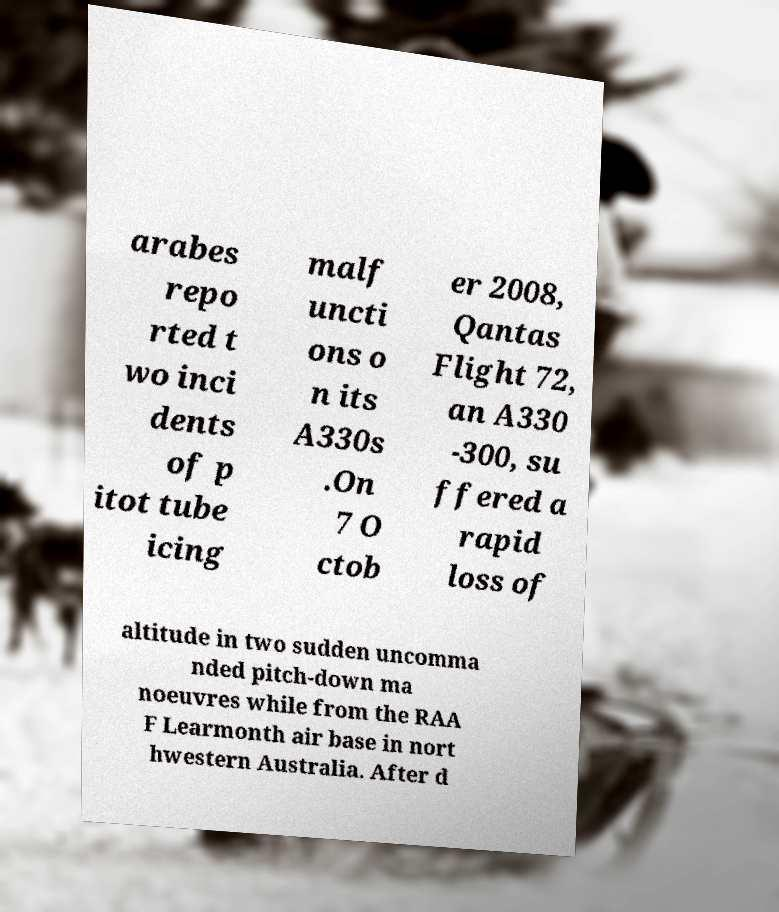Please read and relay the text visible in this image. What does it say? arabes repo rted t wo inci dents of p itot tube icing malf uncti ons o n its A330s .On 7 O ctob er 2008, Qantas Flight 72, an A330 -300, su ffered a rapid loss of altitude in two sudden uncomma nded pitch-down ma noeuvres while from the RAA F Learmonth air base in nort hwestern Australia. After d 